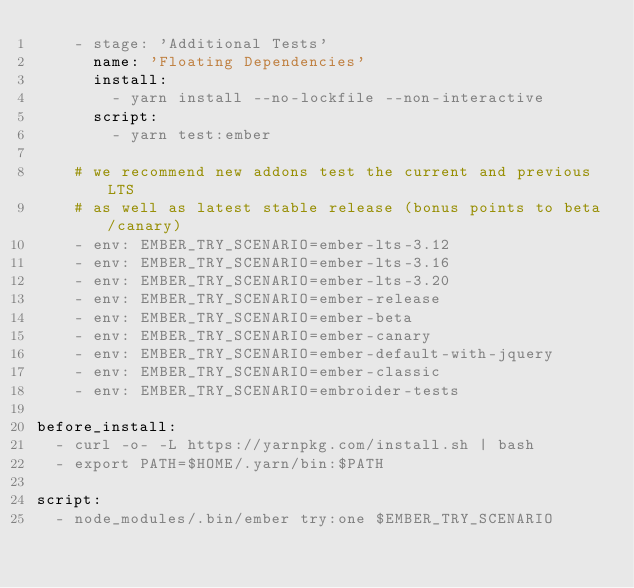Convert code to text. <code><loc_0><loc_0><loc_500><loc_500><_YAML_>    - stage: 'Additional Tests'
      name: 'Floating Dependencies'
      install:
        - yarn install --no-lockfile --non-interactive
      script:
        - yarn test:ember

    # we recommend new addons test the current and previous LTS
    # as well as latest stable release (bonus points to beta/canary)
    - env: EMBER_TRY_SCENARIO=ember-lts-3.12
    - env: EMBER_TRY_SCENARIO=ember-lts-3.16
    - env: EMBER_TRY_SCENARIO=ember-lts-3.20
    - env: EMBER_TRY_SCENARIO=ember-release
    - env: EMBER_TRY_SCENARIO=ember-beta
    - env: EMBER_TRY_SCENARIO=ember-canary
    - env: EMBER_TRY_SCENARIO=ember-default-with-jquery
    - env: EMBER_TRY_SCENARIO=ember-classic
    - env: EMBER_TRY_SCENARIO=embroider-tests

before_install:
  - curl -o- -L https://yarnpkg.com/install.sh | bash
  - export PATH=$HOME/.yarn/bin:$PATH

script:
  - node_modules/.bin/ember try:one $EMBER_TRY_SCENARIO
</code> 